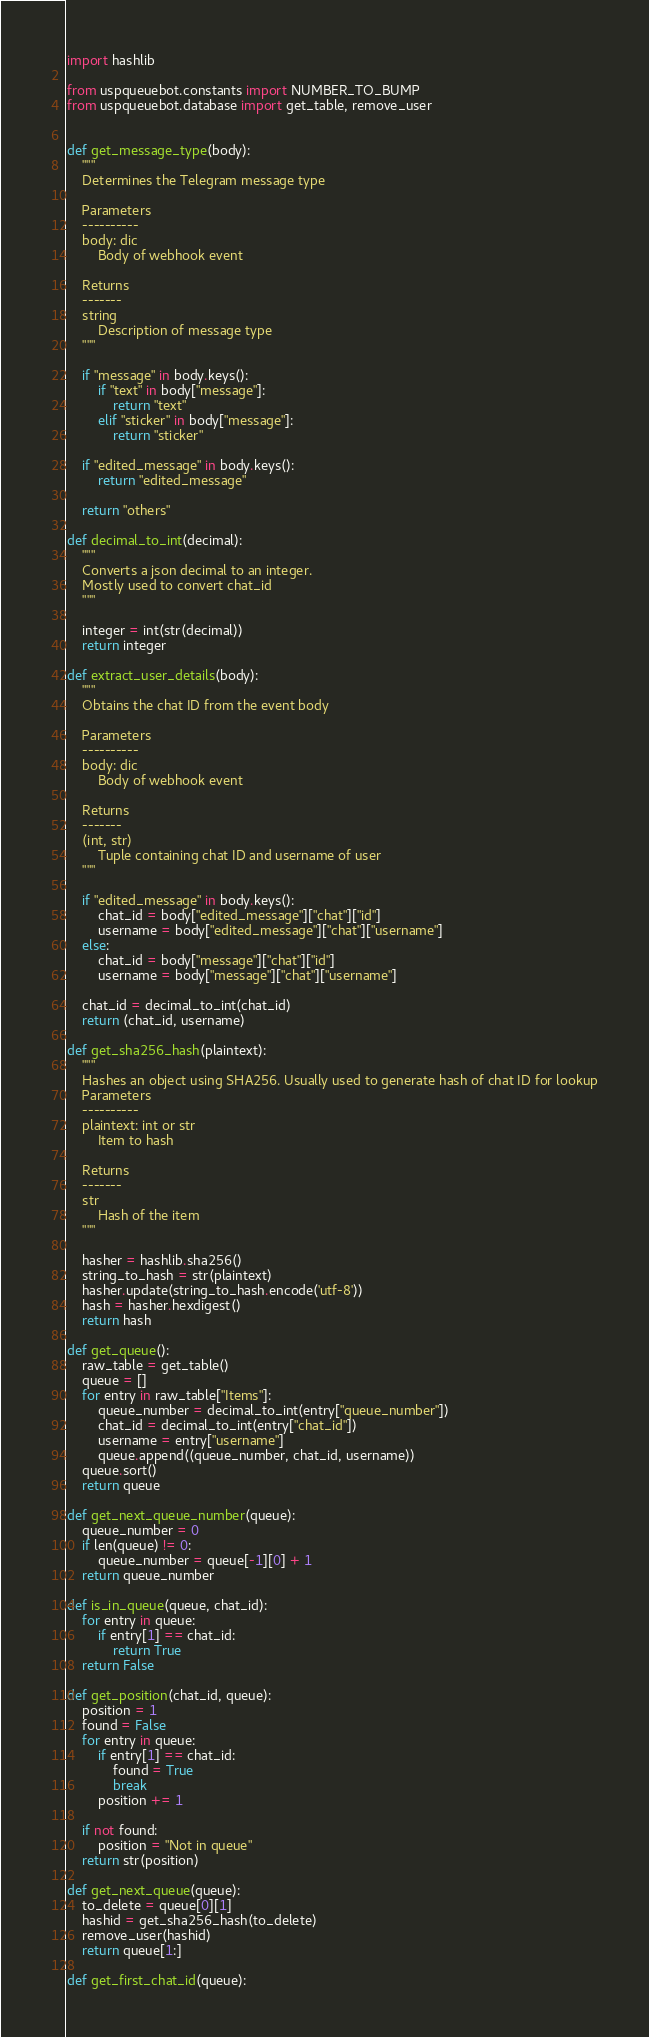Convert code to text. <code><loc_0><loc_0><loc_500><loc_500><_Python_>import hashlib

from uspqueuebot.constants import NUMBER_TO_BUMP
from uspqueuebot.database import get_table, remove_user


def get_message_type(body):
    """
    Determines the Telegram message type

    Parameters
    ----------
    body: dic
        Body of webhook event
    
    Returns
    -------
    string
        Description of message type
    """

    if "message" in body.keys():
        if "text" in body["message"]:
            return "text"
        elif "sticker" in body["message"]:
            return "sticker"
    
    if "edited_message" in body.keys():
        return "edited_message"
    
    return "others"

def decimal_to_int(decimal):
    """
    Converts a json decimal to an integer.
    Mostly used to convert chat_id
    """
    
    integer = int(str(decimal))
    return integer
    
def extract_user_details(body):
    """
    Obtains the chat ID from the event body

    Parameters
    ----------
    body: dic
        Body of webhook event
    
    Returns
    -------
    (int, str)
        Tuple containing chat ID and username of user
    """

    if "edited_message" in body.keys():
        chat_id = body["edited_message"]["chat"]["id"]
        username = body["edited_message"]["chat"]["username"]
    else:
        chat_id = body["message"]["chat"]["id"]
        username = body["message"]["chat"]["username"]

    chat_id = decimal_to_int(chat_id)
    return (chat_id, username)

def get_sha256_hash(plaintext):
    """
    Hashes an object using SHA256. Usually used to generate hash of chat ID for lookup
    Parameters
    ----------
    plaintext: int or str
        Item to hash
    
    Returns
    -------
    str
        Hash of the item
    """

    hasher = hashlib.sha256()
    string_to_hash = str(plaintext)
    hasher.update(string_to_hash.encode('utf-8'))
    hash = hasher.hexdigest()
    return hash

def get_queue():
    raw_table = get_table()
    queue = []
    for entry in raw_table["Items"]:
        queue_number = decimal_to_int(entry["queue_number"])
        chat_id = decimal_to_int(entry["chat_id"])
        username = entry["username"]
        queue.append((queue_number, chat_id, username))
    queue.sort()
    return queue

def get_next_queue_number(queue):
    queue_number = 0
    if len(queue) != 0:
        queue_number = queue[-1][0] + 1
    return queue_number
    
def is_in_queue(queue, chat_id):
    for entry in queue:
        if entry[1] == chat_id:
            return True
    return False

def get_position(chat_id, queue):
    position = 1
    found = False
    for entry in queue:
        if entry[1] == chat_id:
            found = True
            break
        position += 1
    
    if not found:
        position = "Not in queue"
    return str(position)

def get_next_queue(queue):
    to_delete = queue[0][1]
    hashid = get_sha256_hash(to_delete)
    remove_user(hashid)
    return queue[1:]

def get_first_chat_id(queue):</code> 